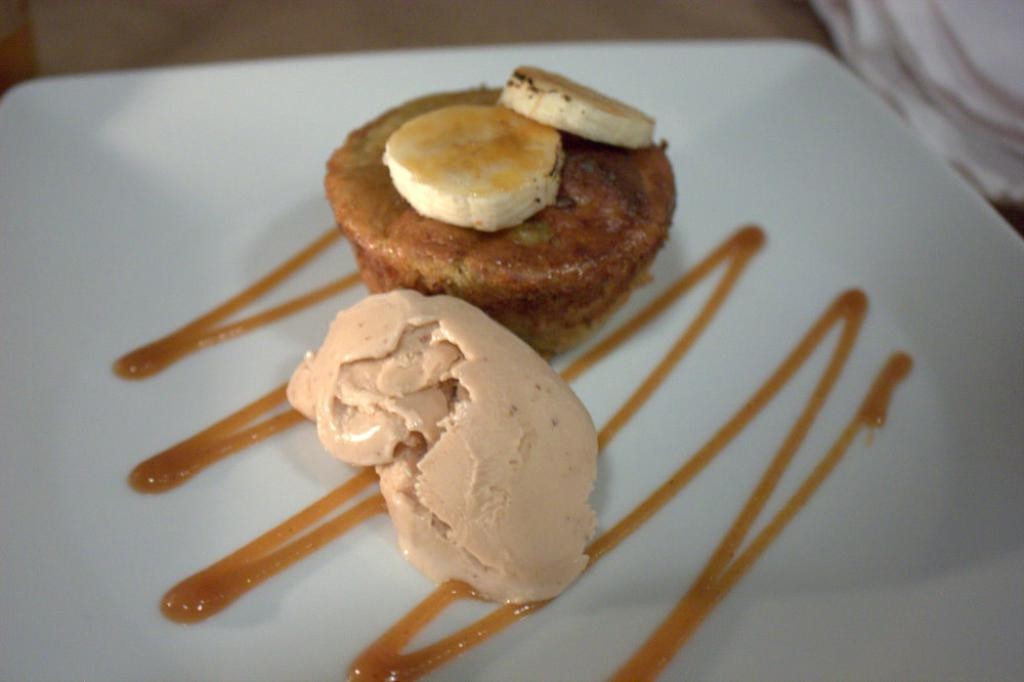What is located in the center of the image? There is a plate in the center of the image. What is on the plate? There is food on the plate. Can you describe anything visible in the background of the image? Unfortunately, the provided facts do not give any information about the objects visible in the background. What type of root vegetable is growing in the camp in the image? There is no camp or root vegetable present in the image. 